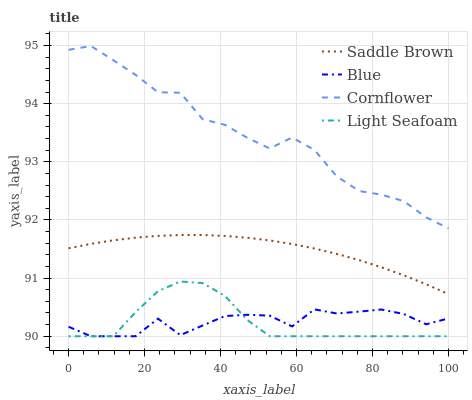Does Light Seafoam have the minimum area under the curve?
Answer yes or no. Yes. Does Cornflower have the maximum area under the curve?
Answer yes or no. Yes. Does Cornflower have the minimum area under the curve?
Answer yes or no. No. Does Light Seafoam have the maximum area under the curve?
Answer yes or no. No. Is Saddle Brown the smoothest?
Answer yes or no. Yes. Is Cornflower the roughest?
Answer yes or no. Yes. Is Light Seafoam the smoothest?
Answer yes or no. No. Is Light Seafoam the roughest?
Answer yes or no. No. Does Blue have the lowest value?
Answer yes or no. Yes. Does Cornflower have the lowest value?
Answer yes or no. No. Does Cornflower have the highest value?
Answer yes or no. Yes. Does Light Seafoam have the highest value?
Answer yes or no. No. Is Blue less than Cornflower?
Answer yes or no. Yes. Is Cornflower greater than Saddle Brown?
Answer yes or no. Yes. Does Blue intersect Light Seafoam?
Answer yes or no. Yes. Is Blue less than Light Seafoam?
Answer yes or no. No. Is Blue greater than Light Seafoam?
Answer yes or no. No. Does Blue intersect Cornflower?
Answer yes or no. No. 